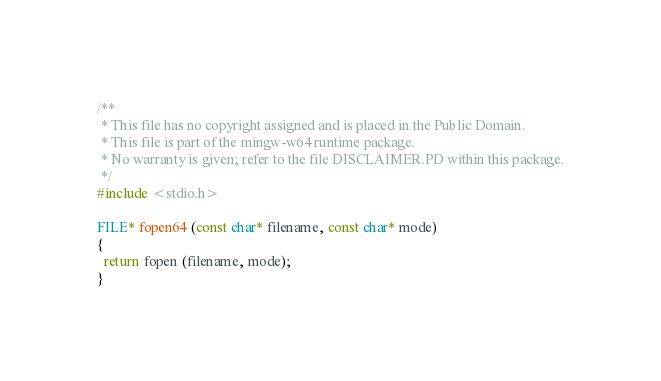Convert code to text. <code><loc_0><loc_0><loc_500><loc_500><_C_>/**
 * This file has no copyright assigned and is placed in the Public Domain.
 * This file is part of the mingw-w64 runtime package.
 * No warranty is given; refer to the file DISCLAIMER.PD within this package.
 */
#include <stdio.h>

FILE* fopen64 (const char* filename, const char* mode)
{
  return fopen (filename, mode);
}
</code> 